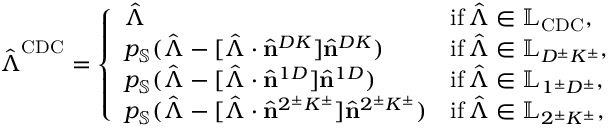<formula> <loc_0><loc_0><loc_500><loc_500>\hat { \Lambda } ^ { C D C } = \left \{ \begin{array} { l l } { \hat { \Lambda } } & { i f \, \hat { \Lambda } \in \mathbb { L } _ { C D C } , } \\ { p _ { \mathbb { S } } ( \hat { \Lambda } - [ \hat { \Lambda } \cdot \hat { n } ^ { D K } ] \hat { n } ^ { D K } ) } & { i f \, \hat { \Lambda } \in \mathbb { L } _ { D ^ { \pm } K ^ { \pm } } , } \\ { p _ { \mathbb { S } } ( \hat { \Lambda } - [ \hat { \Lambda } \cdot \hat { n } ^ { 1 D } ] \hat { n } ^ { 1 D } ) } & { i f \, \hat { \Lambda } \in \mathbb { L } _ { 1 ^ { \pm } D ^ { \pm } } , } \\ { p _ { \mathbb { S } } ( \hat { \Lambda } - [ \hat { \Lambda } \cdot \hat { n } ^ { 2 ^ { \pm } K ^ { \pm } } ] \hat { n } ^ { 2 ^ { \pm } K ^ { \pm } } ) } & { i f \, \hat { \Lambda } \in \mathbb { L } _ { 2 ^ { \pm } K ^ { \pm } } , } \end{array}</formula> 